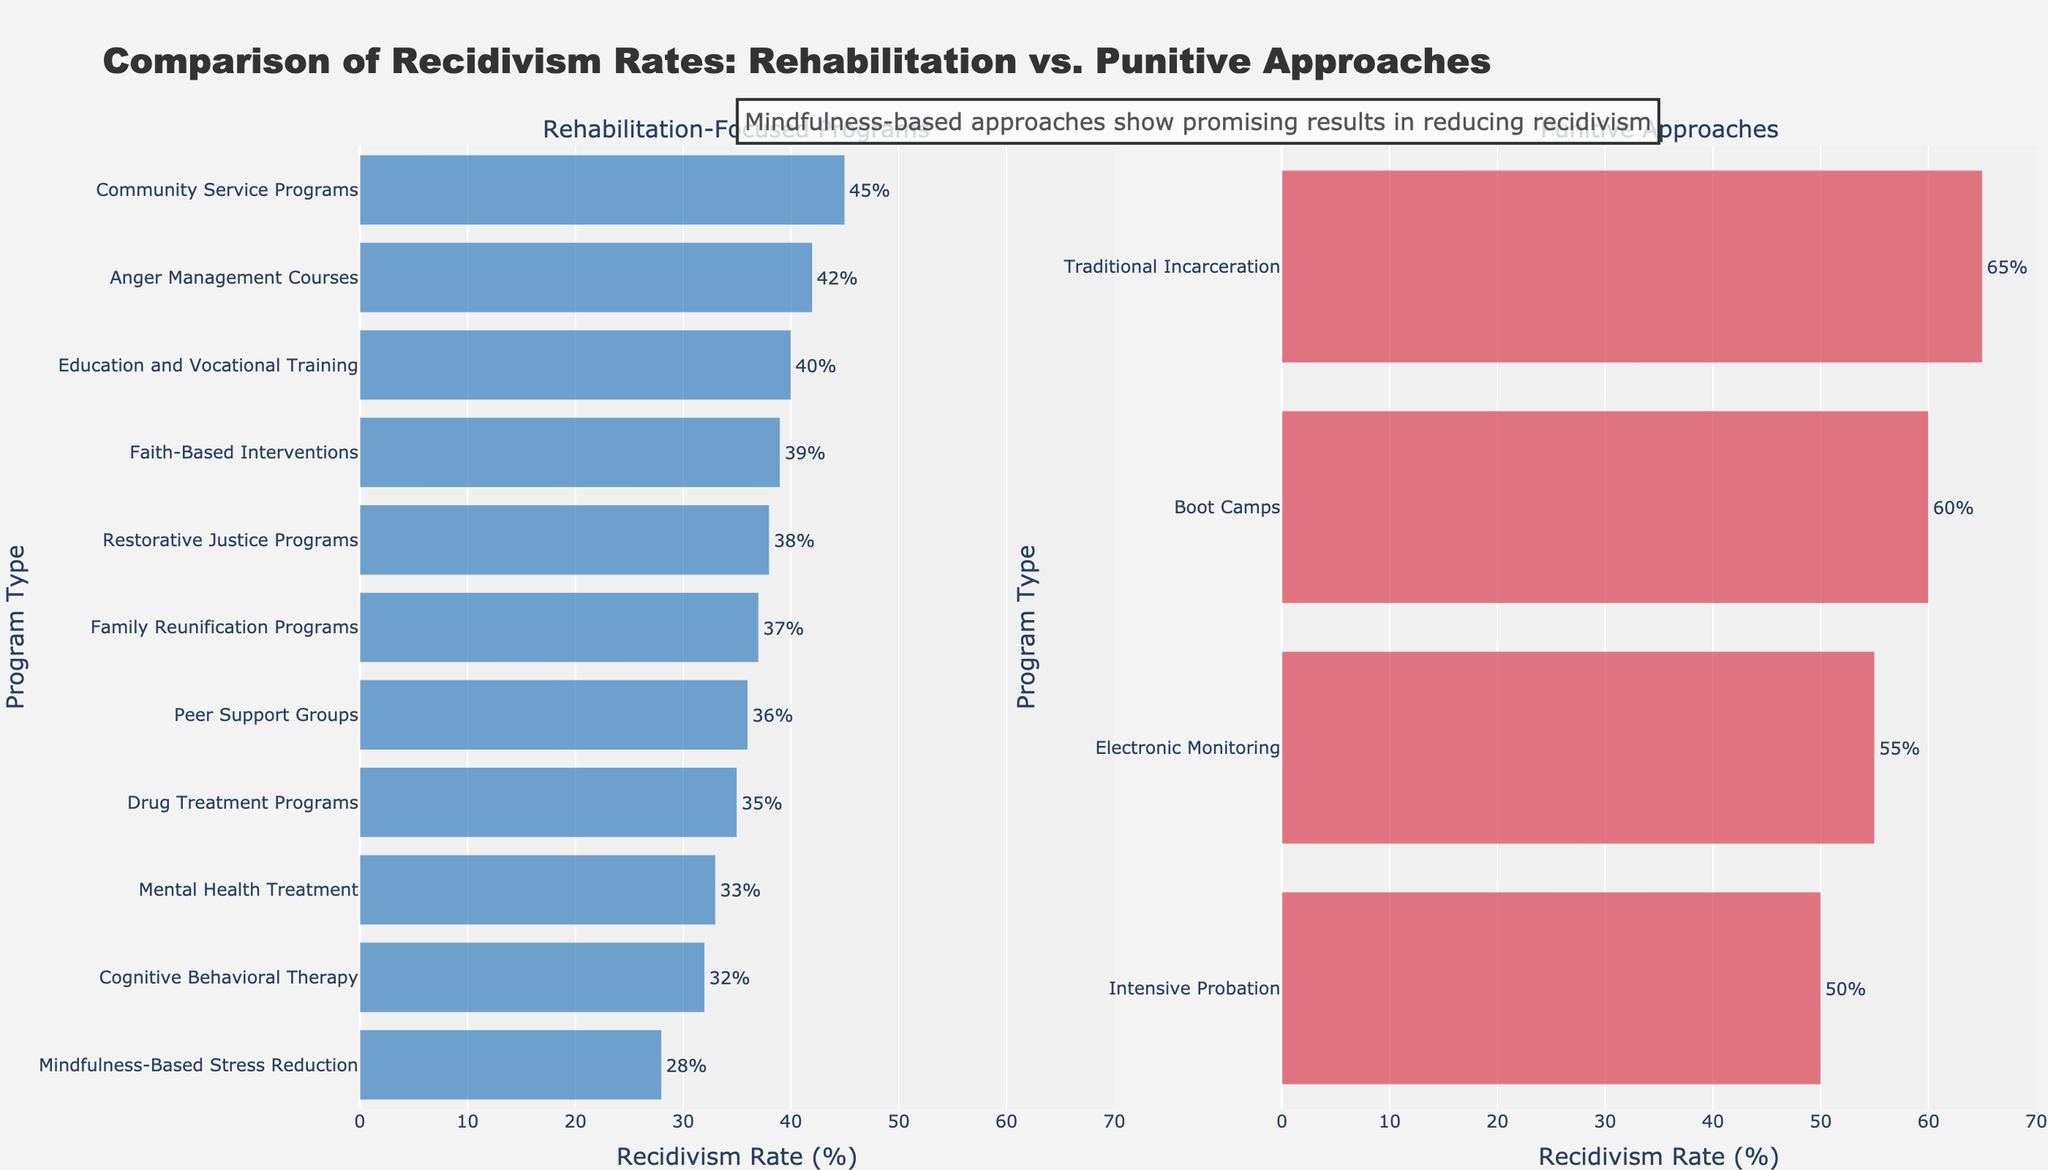Which rehabilitation-focused program has the lowest recidivism rate? The lowest recidivism rate among rehabilitation-focused programs is indicated by the shortest bar in the left subplot, which corresponds to the "Mindfulness-Based Stress Reduction" program at 28%.
Answer: Mindfulness-Based Stress Reduction Which program has the highest recidivism rate among all the programs listed? The highest recidivism rate is represented by the longest bar in either subplot. It corresponds to "Traditional Incarceration" with a recidivism rate of 65%.
Answer: Traditional Incarceration How much higher is the recidivism rate for Electronic Monitoring compared to Cognitive Behavioral Therapy? The recidivism rates for Electronic Monitoring and Cognitive Behavioral Therapy are 55% and 32% respectively. The difference is 55% - 32% = 23%.
Answer: 23% What is the average recidivism rate for the punitive approaches listed? Sum the recidivism rates of the punitive approaches: (65 + 60 + 55 + 50) = 230, then divide by the number of programs, which is 4. The average is 230 / 4 = 57.5%.
Answer: 57.5% How does the recidivism rate of Boot Camps compare to the average recidivism rate of all rehabilitation-focused programs? First, calculate the average recidivism rate of rehabilitation-focused programs: (28 + 32 + 33 + 35 + 36 + 37 + 38 + 39 + 40 + 42 + 45) = 405 / 11 = 36.82%. Boot Camps have a recidivism rate of 60%. Boot Camps' rate is higher than the average rehabilitation rate.
Answer: Boot Camps have a higher rate What is the median recidivism rate for the rehabilitation-focused programs? Listing the rates in order: 28, 32, 33, 35, 36, 37, 38, 39, 40, 42, 45. The median is the middle value, which is the 6th value: 37%.
Answer: 37% What is the difference in recidivism rates between the highest and lowest rehabilitation-focused programs? The highest rate among rehabilitation-focused programs is 45% (Community Service Programs), and the lowest is 28% (Mindfulness-Based Stress Reduction). The difference is 45% - 28% = 17%.
Answer: 17% Which program type shows the smallest visual gap between its recidivism rates and the overall highest recidivism rate? The overall highest recidivism rate is 65% (Traditional Incarceration). The smallest visual gap among all programs occurs with Boot Camps at 60%, showing a small 5% difference.
Answer: Boot Camps Is there a rehabilitation-focused program with a recidivism rate close to the average recidivism rate of punitive approaches? The average recidivism rate for punitive approaches is 57.5%. The closest rehabilitation-focused program's rate is Community Service Programs at 45%, but this is not particularly close.
Answer: No 